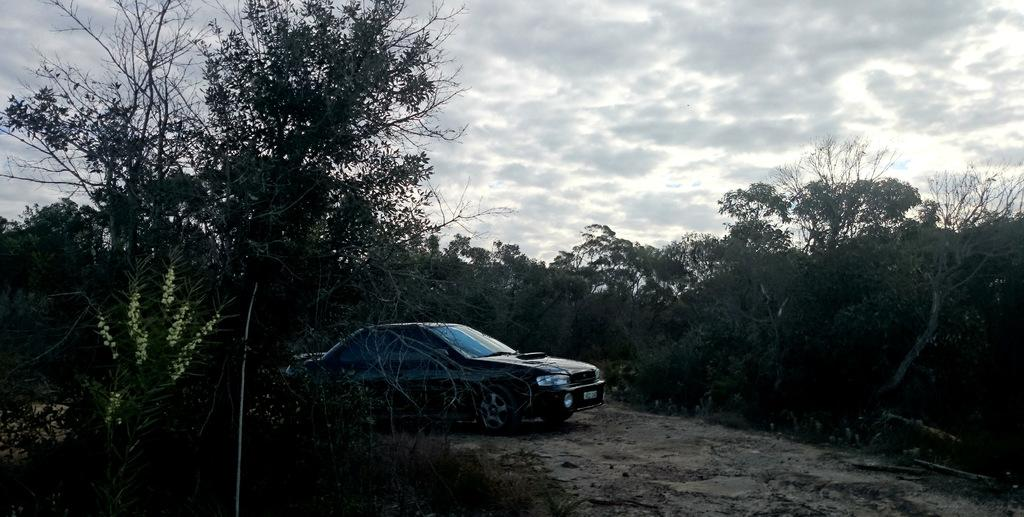What type of vehicle is in the image? There is a black car in the image. Where is the car located? The car is on the road. What other natural elements can be seen in the image? There are plants and trees in the image. What is visible in the background of the image? The sky is visible in the background of the image, and it appears to be cloudy. Where is the advertisement for the faucet located in the image? There is no advertisement or faucet present in the image. 